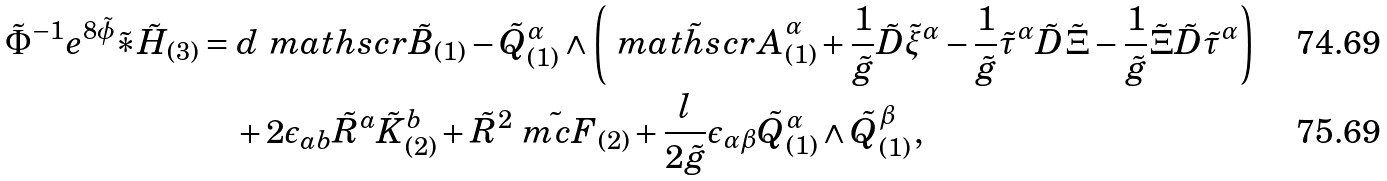<formula> <loc_0><loc_0><loc_500><loc_500>\tilde { \Phi } ^ { - 1 } e ^ { 8 \tilde { \phi } } \tilde { \ast } \tilde { H } _ { ( 3 ) } & = d \ m a t h s c r { \tilde { B } } _ { ( 1 ) } - \tilde { Q } _ { ( 1 ) } ^ { \alpha } \wedge \left ( \tilde { \ m a t h s c r { A } } ^ { \alpha } _ { ( 1 ) } + \frac { 1 } { \tilde { g } } \tilde { D } \tilde { \xi } ^ { \alpha } - \frac { 1 } { \tilde { g } } \tilde { \tau } ^ { \alpha } \tilde { D } \tilde { \Xi } - \frac { 1 } { \tilde { g } } \tilde { \Xi } \tilde { D } \tilde { \tau } ^ { \alpha } \right ) \\ & \quad + 2 \epsilon _ { a b } \tilde { R } ^ { a } \tilde { K } ^ { b } _ { ( 2 ) } + \tilde { R } ^ { 2 } \tilde { \ m c { F } } _ { ( 2 ) } + \frac { l } { 2 \tilde { g } } \epsilon _ { \alpha \beta } \tilde { Q } ^ { \alpha } _ { ( 1 ) } \wedge \tilde { Q } ^ { \beta } _ { ( 1 ) } \, ,</formula> 